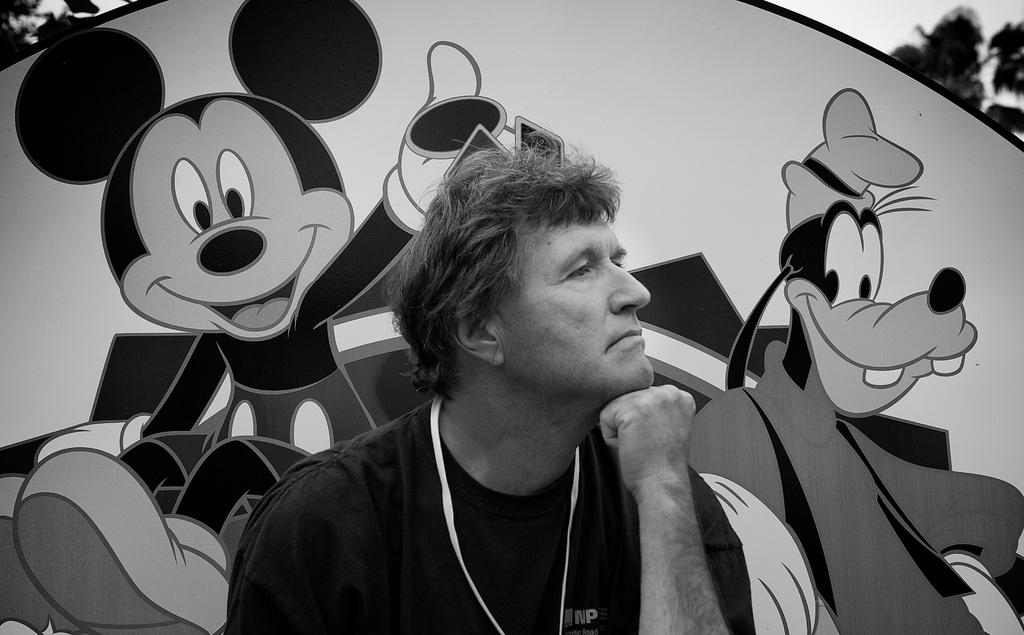What type of living organism can be seen in the image? There is a human in the image. What natural elements are visible in the image? There are trees visible in the image. What is on the back of the human in the image? There is a cartoon board on the back in the image. How many parcels are being delivered by the human in the image? There is no parcel visible in the image, and the human's actions are not described. 